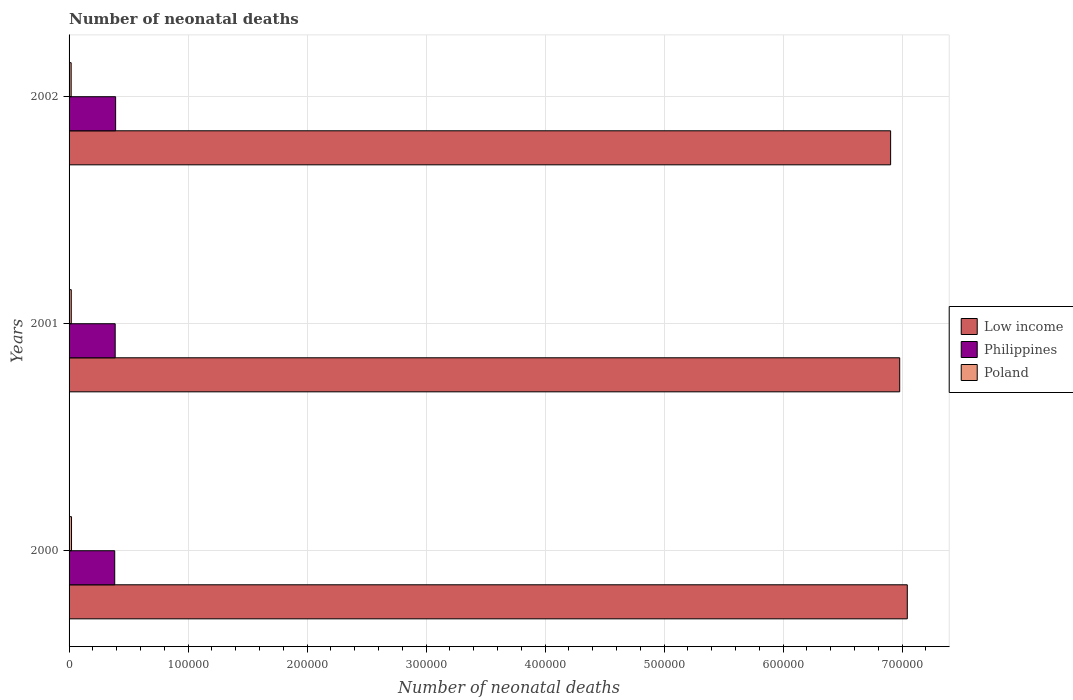How many different coloured bars are there?
Provide a succinct answer. 3. How many groups of bars are there?
Your answer should be very brief. 3. Are the number of bars on each tick of the Y-axis equal?
Ensure brevity in your answer.  Yes. How many bars are there on the 2nd tick from the top?
Provide a short and direct response. 3. How many bars are there on the 1st tick from the bottom?
Your answer should be compact. 3. What is the label of the 1st group of bars from the top?
Offer a terse response. 2002. In how many cases, is the number of bars for a given year not equal to the number of legend labels?
Your answer should be very brief. 0. What is the number of neonatal deaths in in Philippines in 2001?
Provide a succinct answer. 3.88e+04. Across all years, what is the maximum number of neonatal deaths in in Poland?
Your response must be concise. 2060. Across all years, what is the minimum number of neonatal deaths in in Poland?
Your answer should be compact. 1753. In which year was the number of neonatal deaths in in Poland maximum?
Provide a short and direct response. 2000. In which year was the number of neonatal deaths in in Philippines minimum?
Keep it short and to the point. 2000. What is the total number of neonatal deaths in in Philippines in the graph?
Offer a very short reply. 1.16e+05. What is the difference between the number of neonatal deaths in in Poland in 2000 and that in 2002?
Make the answer very short. 307. What is the difference between the number of neonatal deaths in in Philippines in 2000 and the number of neonatal deaths in in Poland in 2002?
Offer a terse response. 3.66e+04. What is the average number of neonatal deaths in in Philippines per year?
Your response must be concise. 3.87e+04. In the year 2000, what is the difference between the number of neonatal deaths in in Poland and number of neonatal deaths in in Low income?
Your answer should be compact. -7.02e+05. What is the ratio of the number of neonatal deaths in in Philippines in 2000 to that in 2002?
Offer a very short reply. 0.98. Is the number of neonatal deaths in in Philippines in 2001 less than that in 2002?
Provide a short and direct response. Yes. Is the difference between the number of neonatal deaths in in Poland in 2001 and 2002 greater than the difference between the number of neonatal deaths in in Low income in 2001 and 2002?
Offer a terse response. No. What is the difference between the highest and the second highest number of neonatal deaths in in Low income?
Offer a terse response. 6386. What is the difference between the highest and the lowest number of neonatal deaths in in Poland?
Your answer should be compact. 307. In how many years, is the number of neonatal deaths in in Poland greater than the average number of neonatal deaths in in Poland taken over all years?
Give a very brief answer. 1. Is the sum of the number of neonatal deaths in in Poland in 2000 and 2001 greater than the maximum number of neonatal deaths in in Low income across all years?
Keep it short and to the point. No. How many bars are there?
Ensure brevity in your answer.  9. Are the values on the major ticks of X-axis written in scientific E-notation?
Provide a succinct answer. No. Does the graph contain any zero values?
Your response must be concise. No. Does the graph contain grids?
Your answer should be very brief. Yes. Where does the legend appear in the graph?
Your response must be concise. Center right. How are the legend labels stacked?
Provide a short and direct response. Vertical. What is the title of the graph?
Provide a short and direct response. Number of neonatal deaths. What is the label or title of the X-axis?
Offer a terse response. Number of neonatal deaths. What is the Number of neonatal deaths in Low income in 2000?
Keep it short and to the point. 7.04e+05. What is the Number of neonatal deaths of Philippines in 2000?
Give a very brief answer. 3.84e+04. What is the Number of neonatal deaths in Poland in 2000?
Keep it short and to the point. 2060. What is the Number of neonatal deaths in Low income in 2001?
Give a very brief answer. 6.98e+05. What is the Number of neonatal deaths in Philippines in 2001?
Provide a short and direct response. 3.88e+04. What is the Number of neonatal deaths in Poland in 2001?
Your answer should be compact. 1845. What is the Number of neonatal deaths of Low income in 2002?
Provide a short and direct response. 6.90e+05. What is the Number of neonatal deaths of Philippines in 2002?
Offer a terse response. 3.91e+04. What is the Number of neonatal deaths of Poland in 2002?
Keep it short and to the point. 1753. Across all years, what is the maximum Number of neonatal deaths in Low income?
Ensure brevity in your answer.  7.04e+05. Across all years, what is the maximum Number of neonatal deaths of Philippines?
Your answer should be compact. 3.91e+04. Across all years, what is the maximum Number of neonatal deaths in Poland?
Offer a terse response. 2060. Across all years, what is the minimum Number of neonatal deaths of Low income?
Your answer should be compact. 6.90e+05. Across all years, what is the minimum Number of neonatal deaths of Philippines?
Make the answer very short. 3.84e+04. Across all years, what is the minimum Number of neonatal deaths in Poland?
Make the answer very short. 1753. What is the total Number of neonatal deaths of Low income in the graph?
Offer a very short reply. 2.09e+06. What is the total Number of neonatal deaths in Philippines in the graph?
Your answer should be very brief. 1.16e+05. What is the total Number of neonatal deaths in Poland in the graph?
Offer a terse response. 5658. What is the difference between the Number of neonatal deaths of Low income in 2000 and that in 2001?
Your answer should be compact. 6386. What is the difference between the Number of neonatal deaths in Philippines in 2000 and that in 2001?
Make the answer very short. -405. What is the difference between the Number of neonatal deaths of Poland in 2000 and that in 2001?
Your answer should be compact. 215. What is the difference between the Number of neonatal deaths in Low income in 2000 and that in 2002?
Your response must be concise. 1.40e+04. What is the difference between the Number of neonatal deaths in Philippines in 2000 and that in 2002?
Provide a short and direct response. -763. What is the difference between the Number of neonatal deaths in Poland in 2000 and that in 2002?
Your answer should be very brief. 307. What is the difference between the Number of neonatal deaths of Low income in 2001 and that in 2002?
Your response must be concise. 7631. What is the difference between the Number of neonatal deaths in Philippines in 2001 and that in 2002?
Give a very brief answer. -358. What is the difference between the Number of neonatal deaths of Poland in 2001 and that in 2002?
Provide a succinct answer. 92. What is the difference between the Number of neonatal deaths in Low income in 2000 and the Number of neonatal deaths in Philippines in 2001?
Your answer should be compact. 6.66e+05. What is the difference between the Number of neonatal deaths in Low income in 2000 and the Number of neonatal deaths in Poland in 2001?
Offer a terse response. 7.03e+05. What is the difference between the Number of neonatal deaths of Philippines in 2000 and the Number of neonatal deaths of Poland in 2001?
Your answer should be very brief. 3.65e+04. What is the difference between the Number of neonatal deaths of Low income in 2000 and the Number of neonatal deaths of Philippines in 2002?
Make the answer very short. 6.65e+05. What is the difference between the Number of neonatal deaths of Low income in 2000 and the Number of neonatal deaths of Poland in 2002?
Provide a short and direct response. 7.03e+05. What is the difference between the Number of neonatal deaths in Philippines in 2000 and the Number of neonatal deaths in Poland in 2002?
Provide a short and direct response. 3.66e+04. What is the difference between the Number of neonatal deaths in Low income in 2001 and the Number of neonatal deaths in Philippines in 2002?
Your answer should be compact. 6.59e+05. What is the difference between the Number of neonatal deaths of Low income in 2001 and the Number of neonatal deaths of Poland in 2002?
Make the answer very short. 6.96e+05. What is the difference between the Number of neonatal deaths in Philippines in 2001 and the Number of neonatal deaths in Poland in 2002?
Offer a very short reply. 3.70e+04. What is the average Number of neonatal deaths of Low income per year?
Your answer should be very brief. 6.98e+05. What is the average Number of neonatal deaths in Philippines per year?
Offer a terse response. 3.87e+04. What is the average Number of neonatal deaths of Poland per year?
Offer a very short reply. 1886. In the year 2000, what is the difference between the Number of neonatal deaths of Low income and Number of neonatal deaths of Philippines?
Give a very brief answer. 6.66e+05. In the year 2000, what is the difference between the Number of neonatal deaths in Low income and Number of neonatal deaths in Poland?
Ensure brevity in your answer.  7.02e+05. In the year 2000, what is the difference between the Number of neonatal deaths of Philippines and Number of neonatal deaths of Poland?
Provide a short and direct response. 3.63e+04. In the year 2001, what is the difference between the Number of neonatal deaths of Low income and Number of neonatal deaths of Philippines?
Offer a terse response. 6.59e+05. In the year 2001, what is the difference between the Number of neonatal deaths of Low income and Number of neonatal deaths of Poland?
Make the answer very short. 6.96e+05. In the year 2001, what is the difference between the Number of neonatal deaths of Philippines and Number of neonatal deaths of Poland?
Offer a very short reply. 3.69e+04. In the year 2002, what is the difference between the Number of neonatal deaths of Low income and Number of neonatal deaths of Philippines?
Keep it short and to the point. 6.51e+05. In the year 2002, what is the difference between the Number of neonatal deaths of Low income and Number of neonatal deaths of Poland?
Provide a short and direct response. 6.89e+05. In the year 2002, what is the difference between the Number of neonatal deaths in Philippines and Number of neonatal deaths in Poland?
Offer a terse response. 3.74e+04. What is the ratio of the Number of neonatal deaths in Low income in 2000 to that in 2001?
Your response must be concise. 1.01. What is the ratio of the Number of neonatal deaths in Poland in 2000 to that in 2001?
Offer a very short reply. 1.12. What is the ratio of the Number of neonatal deaths of Low income in 2000 to that in 2002?
Provide a short and direct response. 1.02. What is the ratio of the Number of neonatal deaths in Philippines in 2000 to that in 2002?
Provide a succinct answer. 0.98. What is the ratio of the Number of neonatal deaths of Poland in 2000 to that in 2002?
Your answer should be compact. 1.18. What is the ratio of the Number of neonatal deaths in Low income in 2001 to that in 2002?
Offer a very short reply. 1.01. What is the ratio of the Number of neonatal deaths of Poland in 2001 to that in 2002?
Your answer should be very brief. 1.05. What is the difference between the highest and the second highest Number of neonatal deaths in Low income?
Offer a terse response. 6386. What is the difference between the highest and the second highest Number of neonatal deaths in Philippines?
Provide a short and direct response. 358. What is the difference between the highest and the second highest Number of neonatal deaths of Poland?
Make the answer very short. 215. What is the difference between the highest and the lowest Number of neonatal deaths of Low income?
Provide a short and direct response. 1.40e+04. What is the difference between the highest and the lowest Number of neonatal deaths of Philippines?
Your answer should be compact. 763. What is the difference between the highest and the lowest Number of neonatal deaths of Poland?
Provide a succinct answer. 307. 